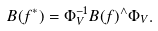<formula> <loc_0><loc_0><loc_500><loc_500>B ( f ^ { * } ) = \Phi _ { V } ^ { - 1 } B ( f ) ^ { \wedge } \Phi _ { V } .</formula> 